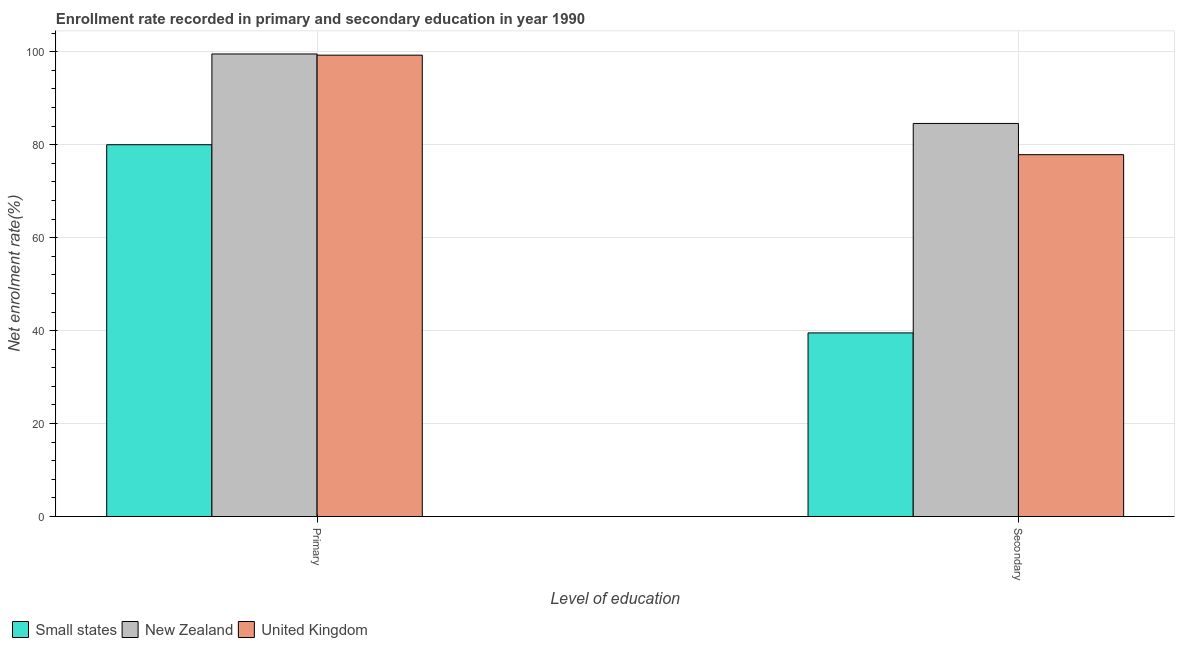How many different coloured bars are there?
Offer a very short reply. 3. What is the label of the 2nd group of bars from the left?
Your response must be concise. Secondary. What is the enrollment rate in primary education in New Zealand?
Offer a very short reply. 99.54. Across all countries, what is the maximum enrollment rate in primary education?
Provide a succinct answer. 99.54. Across all countries, what is the minimum enrollment rate in secondary education?
Ensure brevity in your answer.  39.51. In which country was the enrollment rate in primary education maximum?
Offer a terse response. New Zealand. In which country was the enrollment rate in primary education minimum?
Keep it short and to the point. Small states. What is the total enrollment rate in secondary education in the graph?
Ensure brevity in your answer.  201.96. What is the difference between the enrollment rate in secondary education in Small states and that in United Kingdom?
Your answer should be compact. -38.35. What is the difference between the enrollment rate in secondary education in Small states and the enrollment rate in primary education in United Kingdom?
Your response must be concise. -59.77. What is the average enrollment rate in primary education per country?
Ensure brevity in your answer.  92.94. What is the difference between the enrollment rate in primary education and enrollment rate in secondary education in New Zealand?
Your answer should be compact. 14.96. In how many countries, is the enrollment rate in primary education greater than 68 %?
Your answer should be very brief. 3. What is the ratio of the enrollment rate in secondary education in Small states to that in United Kingdom?
Your answer should be very brief. 0.51. In how many countries, is the enrollment rate in secondary education greater than the average enrollment rate in secondary education taken over all countries?
Keep it short and to the point. 2. What does the 1st bar from the left in Primary represents?
Give a very brief answer. Small states. What does the 2nd bar from the right in Primary represents?
Keep it short and to the point. New Zealand. How many countries are there in the graph?
Give a very brief answer. 3. Does the graph contain any zero values?
Make the answer very short. No. Does the graph contain grids?
Keep it short and to the point. Yes. How many legend labels are there?
Your response must be concise. 3. What is the title of the graph?
Your response must be concise. Enrollment rate recorded in primary and secondary education in year 1990. What is the label or title of the X-axis?
Your answer should be very brief. Level of education. What is the label or title of the Y-axis?
Ensure brevity in your answer.  Net enrolment rate(%). What is the Net enrolment rate(%) of Small states in Primary?
Your answer should be compact. 80.01. What is the Net enrolment rate(%) in New Zealand in Primary?
Offer a terse response. 99.54. What is the Net enrolment rate(%) in United Kingdom in Primary?
Your response must be concise. 99.28. What is the Net enrolment rate(%) in Small states in Secondary?
Offer a very short reply. 39.51. What is the Net enrolment rate(%) in New Zealand in Secondary?
Keep it short and to the point. 84.58. What is the Net enrolment rate(%) in United Kingdom in Secondary?
Your answer should be compact. 77.86. Across all Level of education, what is the maximum Net enrolment rate(%) of Small states?
Give a very brief answer. 80.01. Across all Level of education, what is the maximum Net enrolment rate(%) in New Zealand?
Provide a short and direct response. 99.54. Across all Level of education, what is the maximum Net enrolment rate(%) of United Kingdom?
Provide a succinct answer. 99.28. Across all Level of education, what is the minimum Net enrolment rate(%) in Small states?
Offer a terse response. 39.51. Across all Level of education, what is the minimum Net enrolment rate(%) of New Zealand?
Provide a short and direct response. 84.58. Across all Level of education, what is the minimum Net enrolment rate(%) of United Kingdom?
Your response must be concise. 77.86. What is the total Net enrolment rate(%) in Small states in the graph?
Provide a short and direct response. 119.52. What is the total Net enrolment rate(%) of New Zealand in the graph?
Offer a very short reply. 184.12. What is the total Net enrolment rate(%) in United Kingdom in the graph?
Offer a terse response. 177.14. What is the difference between the Net enrolment rate(%) of Small states in Primary and that in Secondary?
Provide a short and direct response. 40.5. What is the difference between the Net enrolment rate(%) in New Zealand in Primary and that in Secondary?
Your answer should be compact. 14.96. What is the difference between the Net enrolment rate(%) in United Kingdom in Primary and that in Secondary?
Give a very brief answer. 21.41. What is the difference between the Net enrolment rate(%) of Small states in Primary and the Net enrolment rate(%) of New Zealand in Secondary?
Give a very brief answer. -4.58. What is the difference between the Net enrolment rate(%) of Small states in Primary and the Net enrolment rate(%) of United Kingdom in Secondary?
Provide a succinct answer. 2.14. What is the difference between the Net enrolment rate(%) in New Zealand in Primary and the Net enrolment rate(%) in United Kingdom in Secondary?
Your response must be concise. 21.67. What is the average Net enrolment rate(%) in Small states per Level of education?
Your answer should be compact. 59.76. What is the average Net enrolment rate(%) of New Zealand per Level of education?
Provide a short and direct response. 92.06. What is the average Net enrolment rate(%) of United Kingdom per Level of education?
Offer a very short reply. 88.57. What is the difference between the Net enrolment rate(%) in Small states and Net enrolment rate(%) in New Zealand in Primary?
Provide a succinct answer. -19.53. What is the difference between the Net enrolment rate(%) in Small states and Net enrolment rate(%) in United Kingdom in Primary?
Your answer should be compact. -19.27. What is the difference between the Net enrolment rate(%) in New Zealand and Net enrolment rate(%) in United Kingdom in Primary?
Keep it short and to the point. 0.26. What is the difference between the Net enrolment rate(%) of Small states and Net enrolment rate(%) of New Zealand in Secondary?
Ensure brevity in your answer.  -45.07. What is the difference between the Net enrolment rate(%) of Small states and Net enrolment rate(%) of United Kingdom in Secondary?
Your answer should be very brief. -38.35. What is the difference between the Net enrolment rate(%) in New Zealand and Net enrolment rate(%) in United Kingdom in Secondary?
Provide a succinct answer. 6.72. What is the ratio of the Net enrolment rate(%) of Small states in Primary to that in Secondary?
Your answer should be very brief. 2.02. What is the ratio of the Net enrolment rate(%) of New Zealand in Primary to that in Secondary?
Give a very brief answer. 1.18. What is the ratio of the Net enrolment rate(%) in United Kingdom in Primary to that in Secondary?
Your answer should be compact. 1.27. What is the difference between the highest and the second highest Net enrolment rate(%) in Small states?
Your answer should be very brief. 40.5. What is the difference between the highest and the second highest Net enrolment rate(%) of New Zealand?
Give a very brief answer. 14.96. What is the difference between the highest and the second highest Net enrolment rate(%) in United Kingdom?
Your answer should be compact. 21.41. What is the difference between the highest and the lowest Net enrolment rate(%) of Small states?
Keep it short and to the point. 40.5. What is the difference between the highest and the lowest Net enrolment rate(%) of New Zealand?
Give a very brief answer. 14.96. What is the difference between the highest and the lowest Net enrolment rate(%) in United Kingdom?
Your response must be concise. 21.41. 